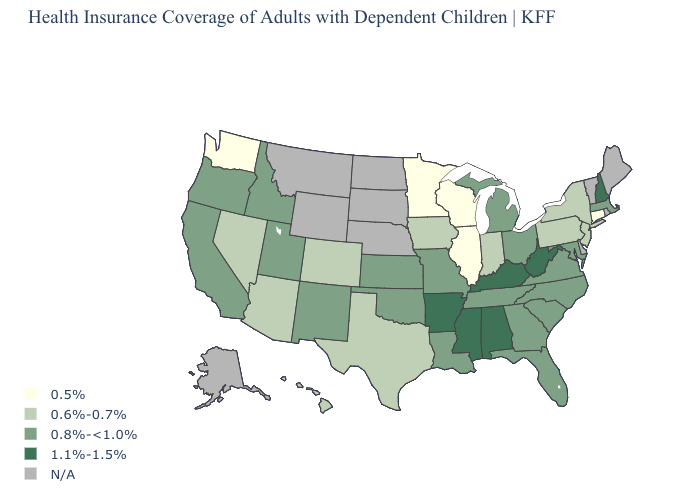What is the lowest value in the USA?
Quick response, please. 0.5%. Name the states that have a value in the range 0.5%?
Quick response, please. Connecticut, Illinois, Minnesota, Washington, Wisconsin. Does Connecticut have the lowest value in the USA?
Quick response, please. Yes. Which states hav the highest value in the West?
Concise answer only. California, Idaho, New Mexico, Oregon, Utah. Among the states that border Indiana , does Kentucky have the highest value?
Write a very short answer. Yes. What is the lowest value in the MidWest?
Answer briefly. 0.5%. Among the states that border Georgia , does Alabama have the lowest value?
Write a very short answer. No. Name the states that have a value in the range 0.8%-<1.0%?
Short answer required. California, Florida, Georgia, Idaho, Kansas, Louisiana, Maryland, Massachusetts, Michigan, Missouri, New Mexico, North Carolina, Ohio, Oklahoma, Oregon, South Carolina, Tennessee, Utah, Virginia. Among the states that border Arizona , does Nevada have the lowest value?
Give a very brief answer. Yes. Name the states that have a value in the range 1.1%-1.5%?
Short answer required. Alabama, Arkansas, Kentucky, Mississippi, New Hampshire, West Virginia. What is the value of Utah?
Write a very short answer. 0.8%-<1.0%. What is the value of Louisiana?
Keep it brief. 0.8%-<1.0%. What is the value of Virginia?
Quick response, please. 0.8%-<1.0%. What is the value of Indiana?
Write a very short answer. 0.6%-0.7%. 